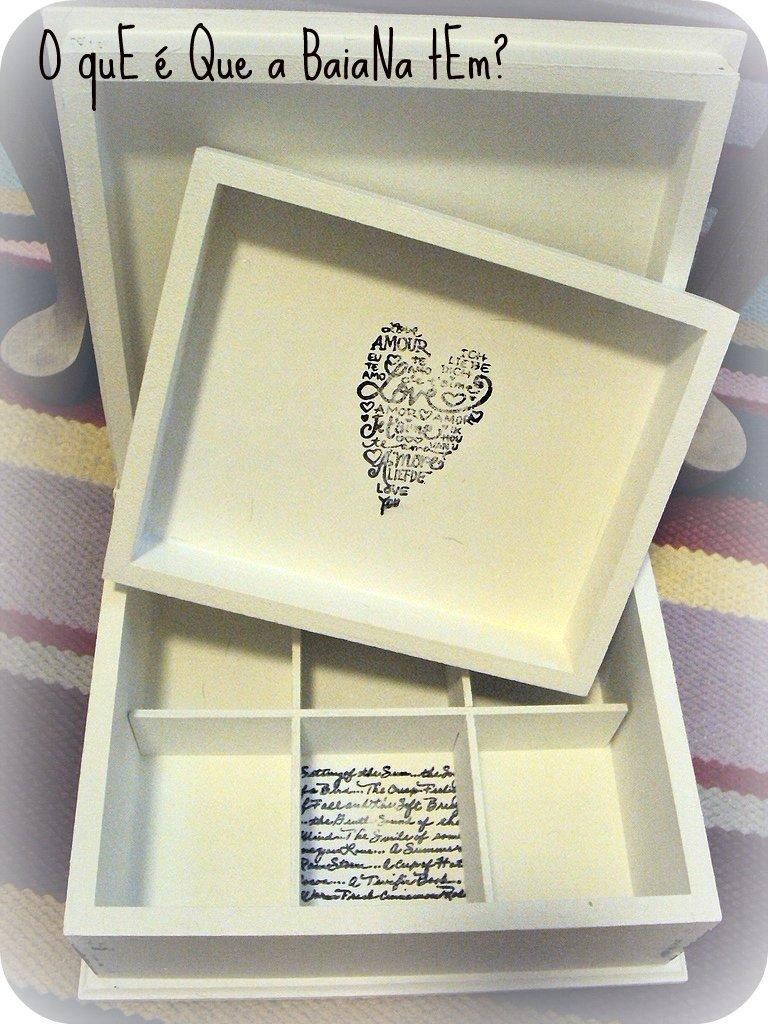<image>
Write a terse but informative summary of the picture. A heart made up of words has the word love in the middle. 